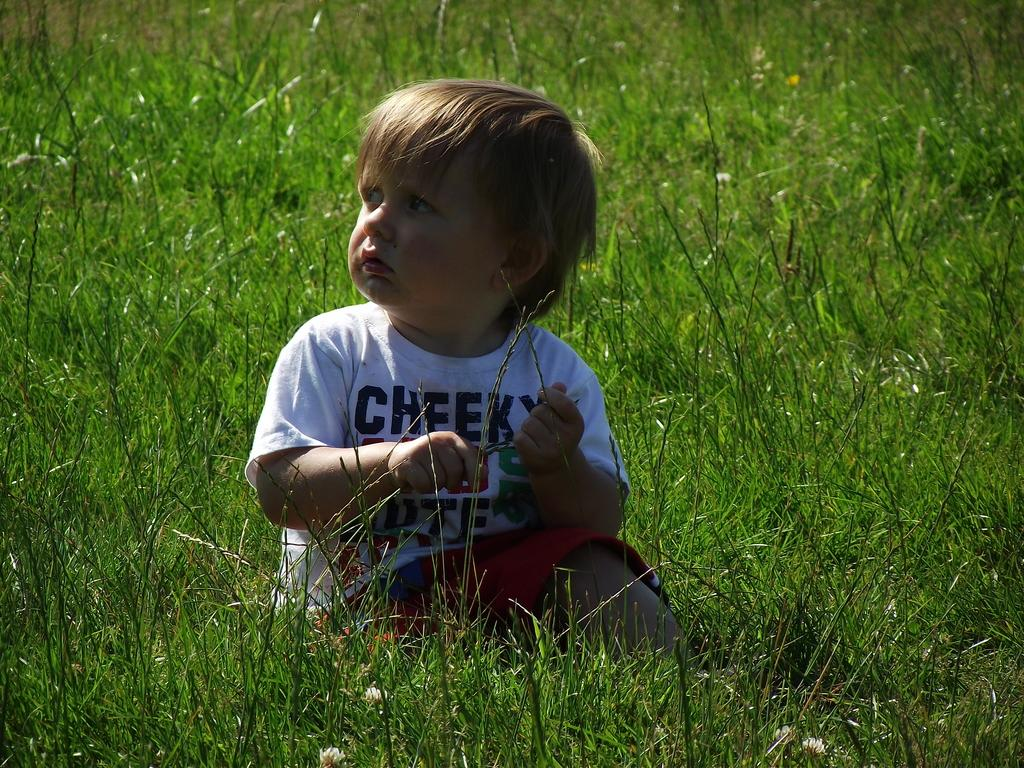What is the main subject of the image? The main subject of the image is a kid. What can be seen in the background of the image? There is grass visible in the background of the image. Is there a tiger lurking in the grass in the image? No, there is no tiger present in the image. 